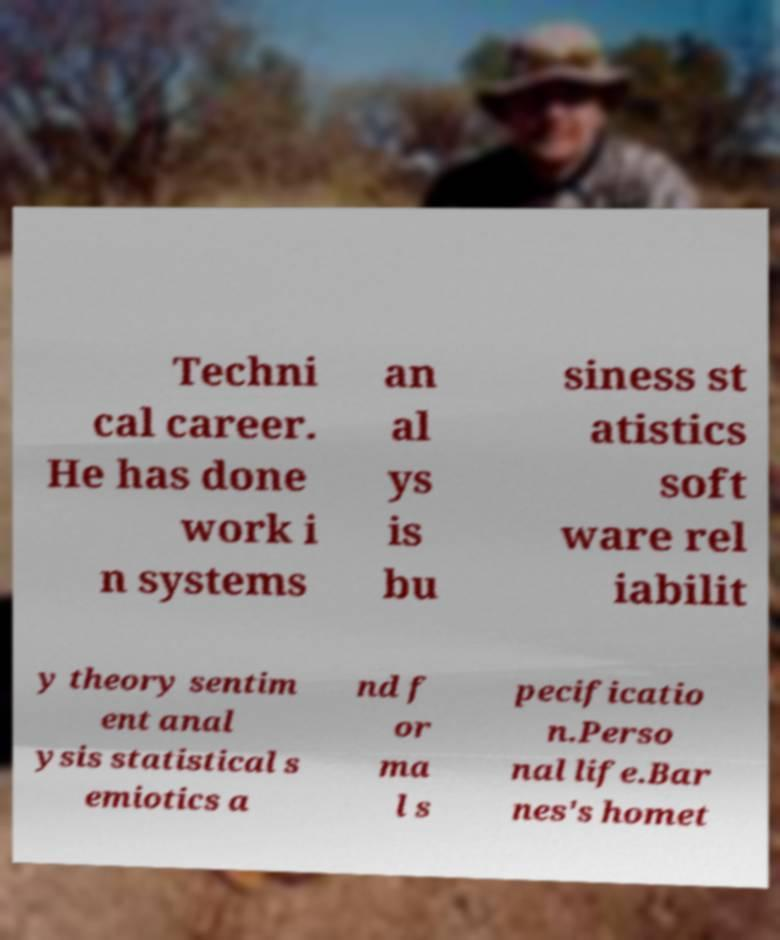For documentation purposes, I need the text within this image transcribed. Could you provide that? Techni cal career. He has done work i n systems an al ys is bu siness st atistics soft ware rel iabilit y theory sentim ent anal ysis statistical s emiotics a nd f or ma l s pecificatio n.Perso nal life.Bar nes's homet 